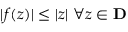Convert formula to latex. <formula><loc_0><loc_0><loc_500><loc_500>| f ( z ) | \leq | z | \ \forall z \in D</formula> 